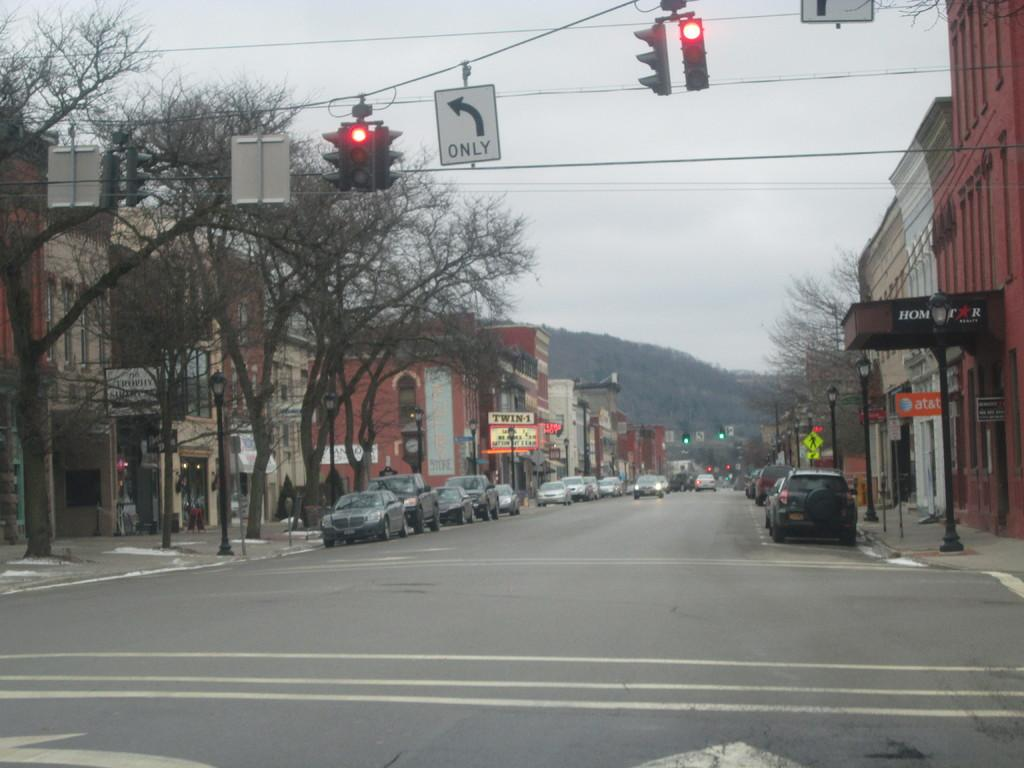Provide a one-sentence caption for the provided image. Two traffic lights are red for both going straight and turning left only. 